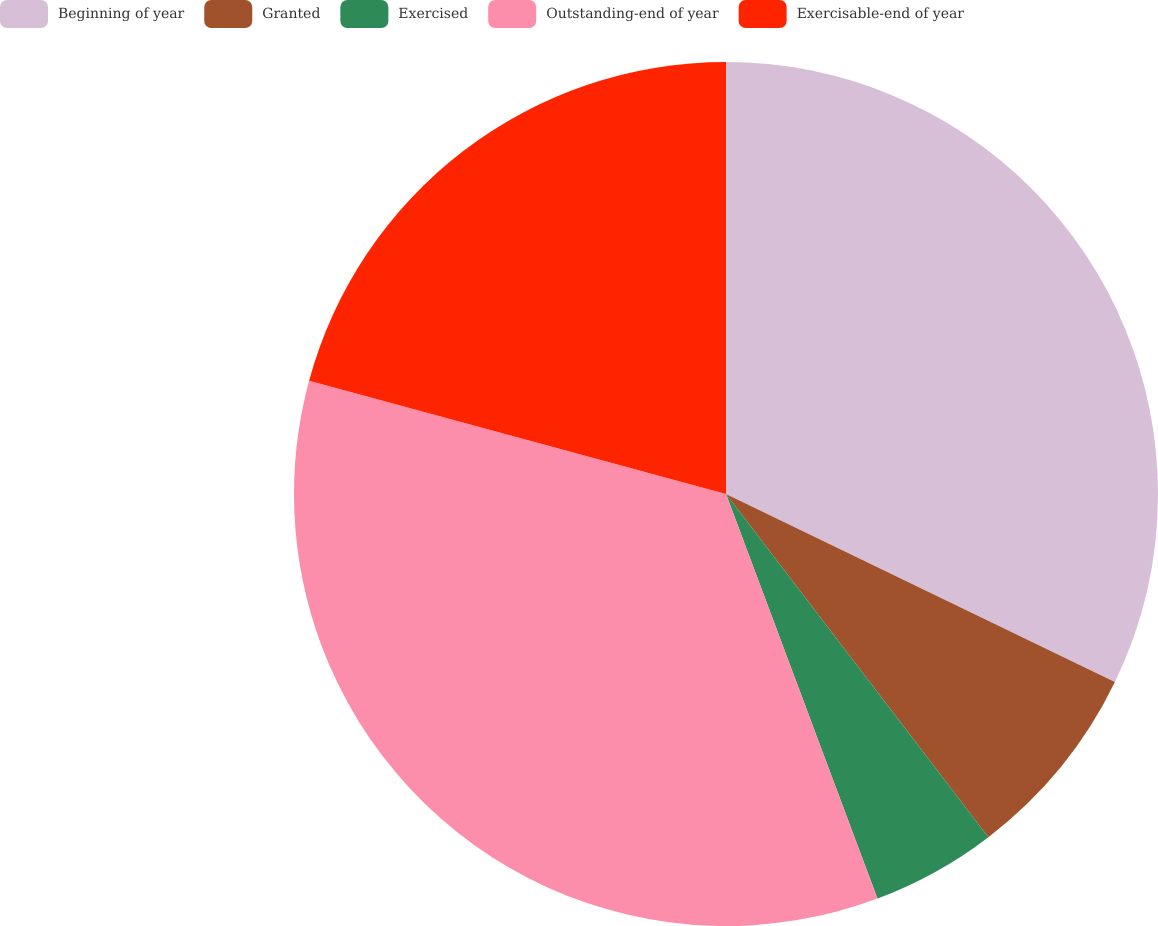<chart> <loc_0><loc_0><loc_500><loc_500><pie_chart><fcel>Beginning of year<fcel>Granted<fcel>Exercised<fcel>Outstanding-end of year<fcel>Exercisable-end of year<nl><fcel>32.17%<fcel>7.44%<fcel>4.69%<fcel>34.92%<fcel>20.78%<nl></chart> 